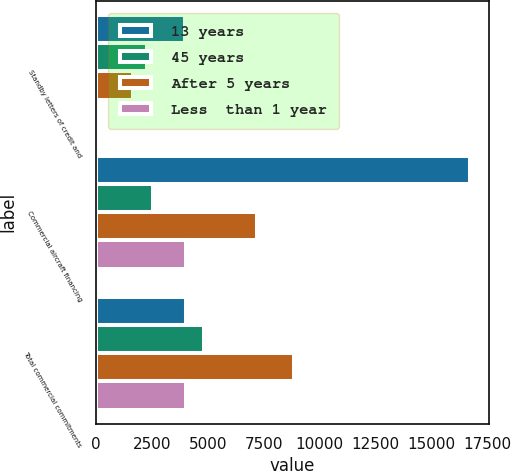Convert chart. <chart><loc_0><loc_0><loc_500><loc_500><stacked_bar_chart><ecel><fcel>Standby letters of credit and<fcel>Commercial aircraft financing<fcel>Total commercial commitments<nl><fcel>13 years<fcel>3985<fcel>16723<fcel>4043<nl><fcel>45 years<fcel>2277<fcel>2552<fcel>4829<nl><fcel>After 5 years<fcel>1658<fcel>7207<fcel>8865<nl><fcel>Less  than 1 year<fcel>1<fcel>4043<fcel>4044<nl></chart> 